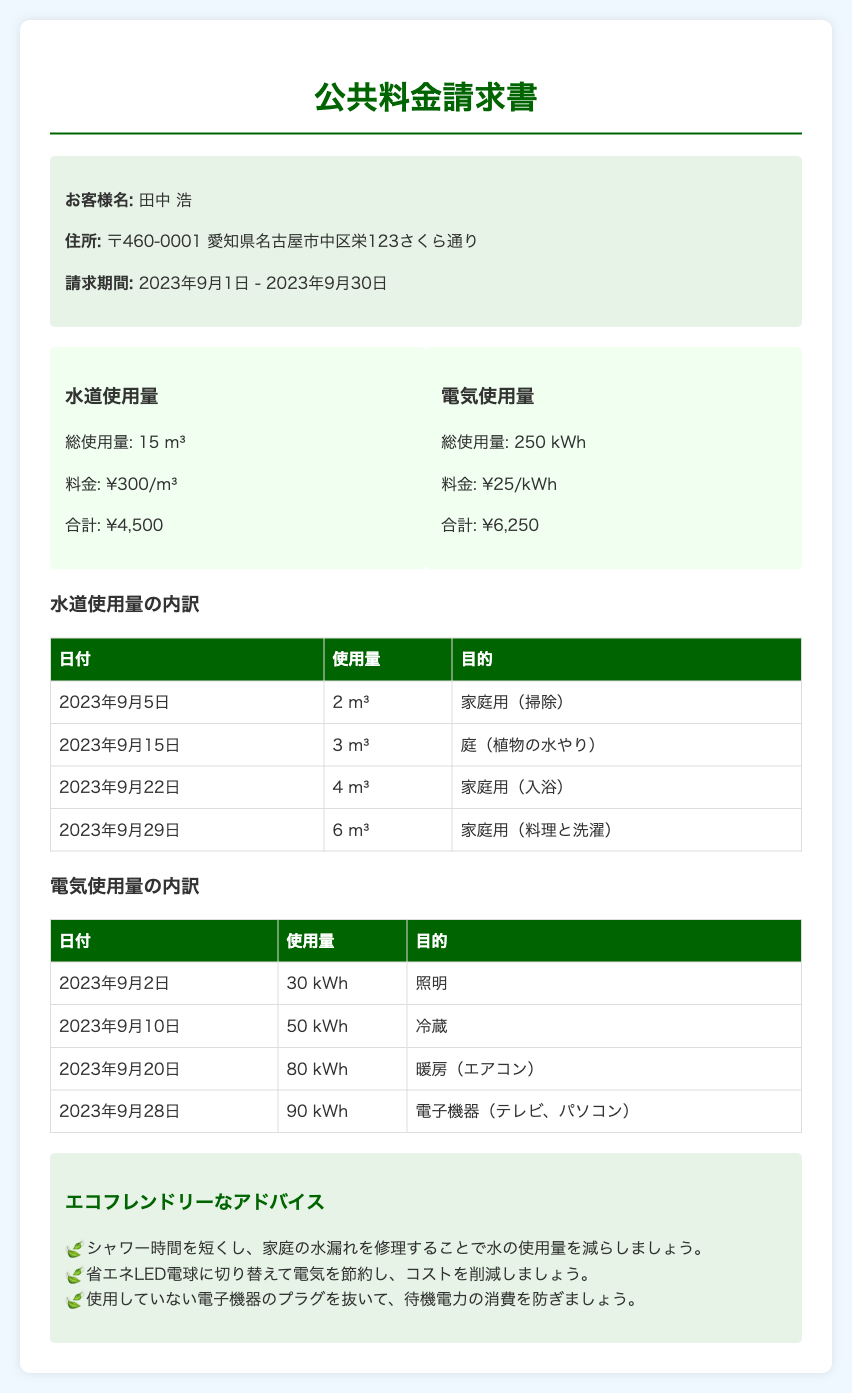お客様名は誰ですか？ お客様名は請求書の顧客情報セクションに記載されており、田中 浩です。
Answer: 田中 浩 請求期間はいつですか？ 請求期間は請求書に記載されており、2023年9月1日から2023年9月30日までです。
Answer: 2023年9月1日 - 2023年9月30日 水道の総使用量は何立方メートルですか？ 水道の総使用量は水道使用量セクションに記載されており、15 m³です。
Answer: 15 m³ 電気の総使用量は何キロワット時ですか？ 電気の総使用量は電気使用量セクションに記載されており、250 kWhです。
Answer: 250 kWh 水道料金の合計はいくらですか？ 水道料金の合計は水道使用量の合計に基づいて計算され、¥4,500です。
Answer: ¥4,500 電気料金の合計はいくらですか？ 電気料金の合計は電気使用量の合計に基づいて計算され、¥6,250です。
Answer: ¥6,250 9月22日に家庭用での水道使用量は何立方メートルですか？ 9月22日の水道使用量は水道使用量の内訳テーブルに記載されており、4 m³です。
Answer: 4 m³ 省エネLED電球に切り替えることは何のためですか？ 省エネLED電球に切り替える理由はエコフレンドリーなアドバイス欄に記載されており、電気を節約するためです。
Answer: 電気を節約 9月28日の電気使用量は何キロワット時ですか？ 9月28日の電気使用量は電気の内訳テーブルに記載されており、90 kWhです。
Answer: 90 kWh 